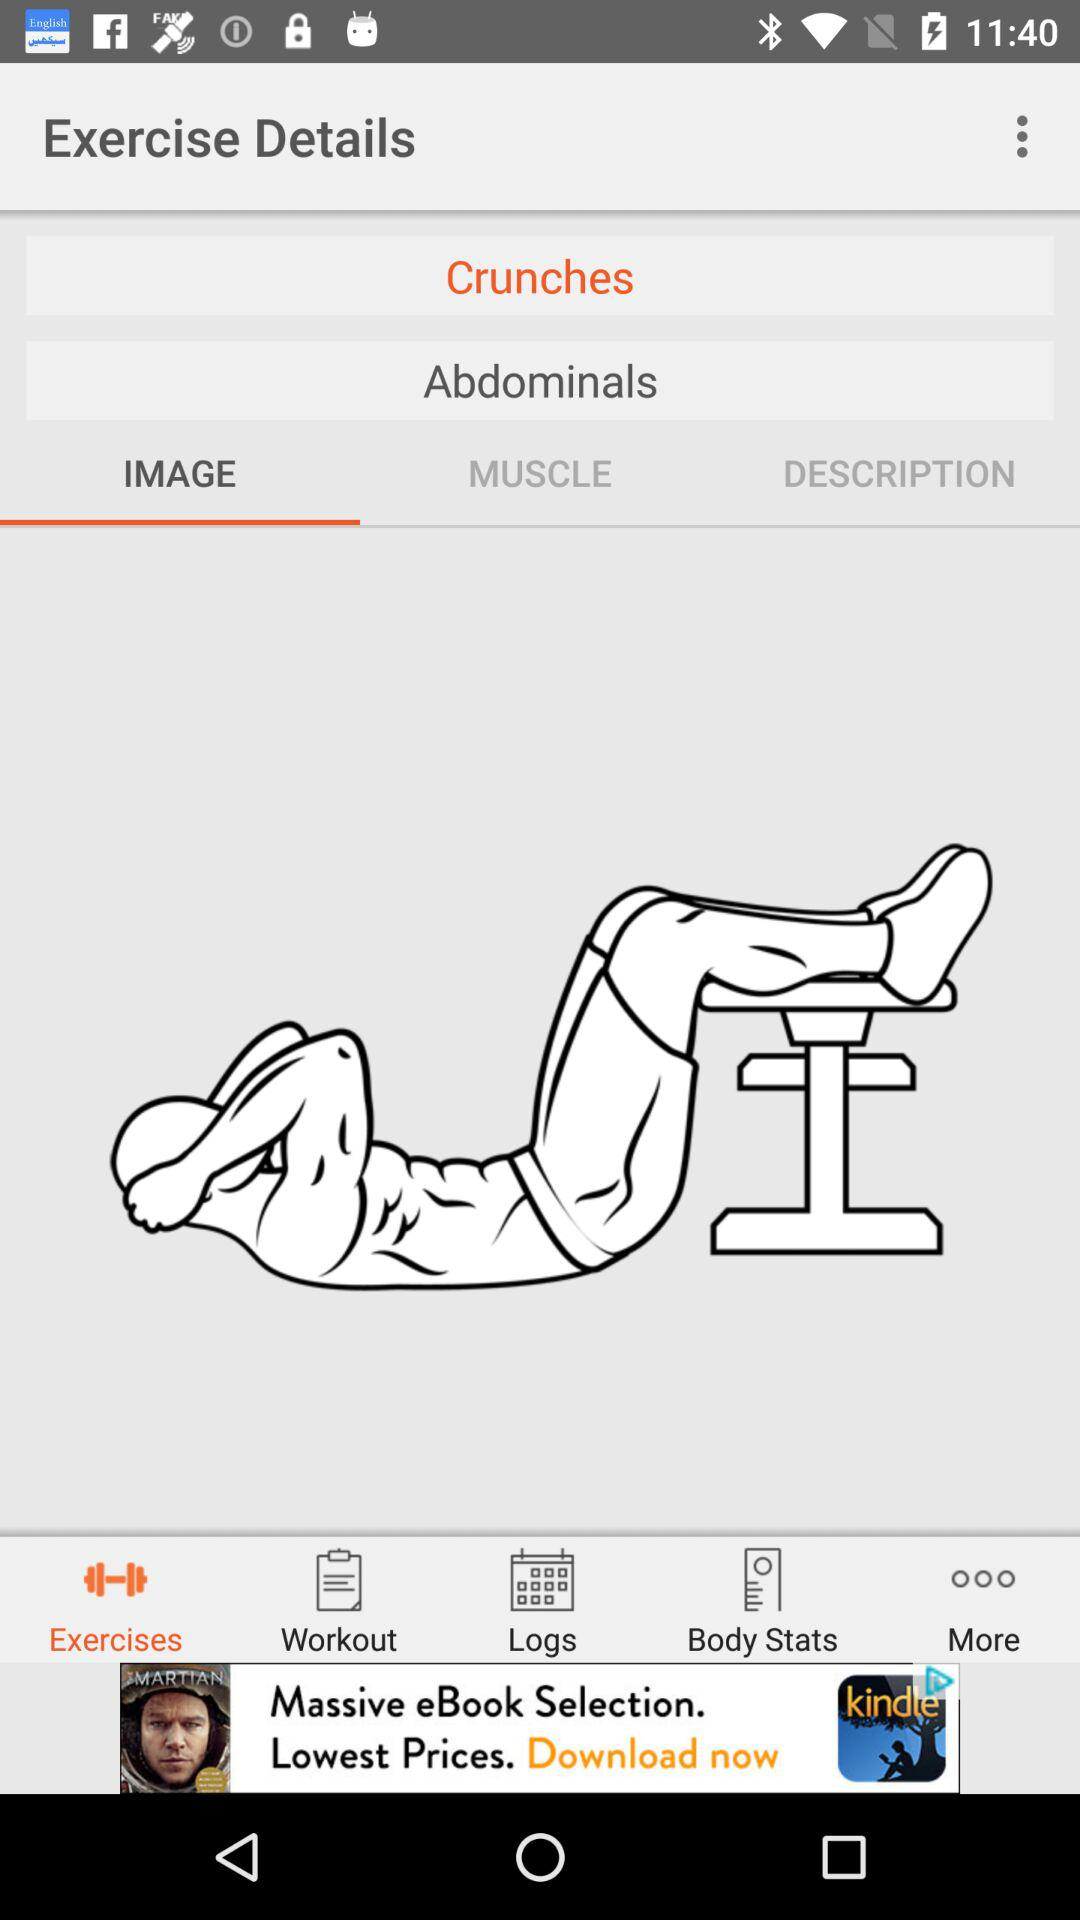What part of the body is this exercise for? This exercise is for the "Abdominals". 